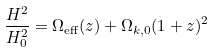Convert formula to latex. <formula><loc_0><loc_0><loc_500><loc_500>\frac { H ^ { 2 } } { H _ { 0 } ^ { 2 } } = \Omega _ { \text {eff} } ( z ) + \Omega _ { k , 0 } ( 1 + z ) ^ { 2 }</formula> 